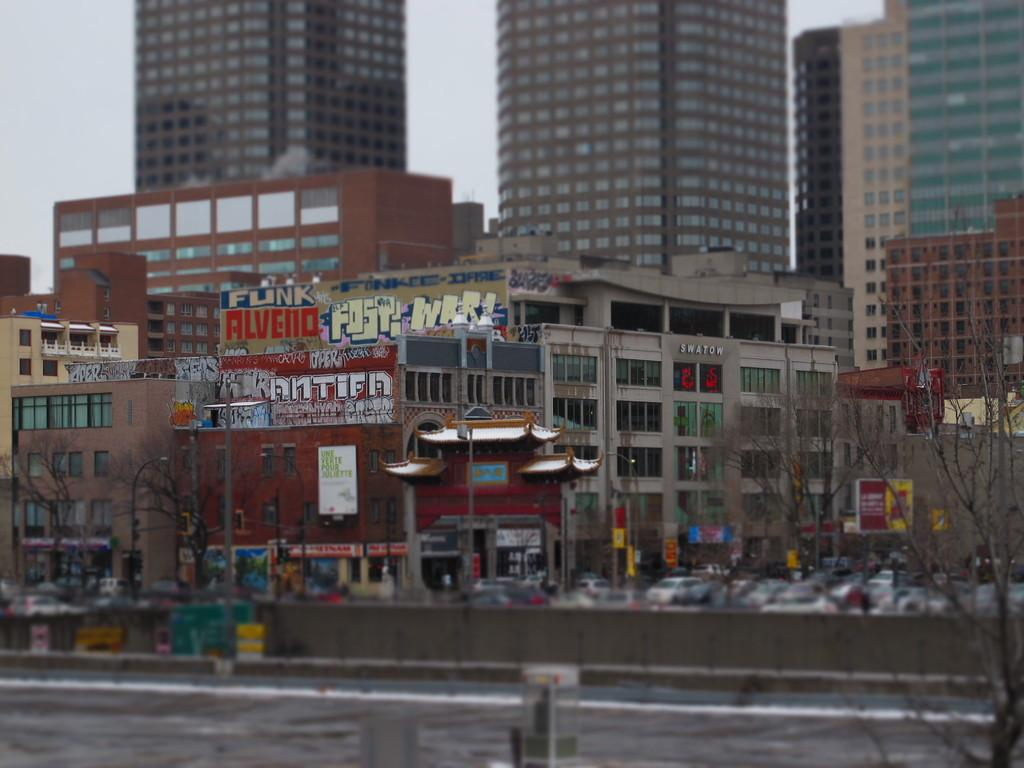What type of structures can be seen in the image? There are buildings in the image. What is located at the bottom of the image? There is a road at the bottom of the image. What is moving along the road in the image? Vehicles are visible on the road. What are the vertical structures in the image? There are poles in the image. What type of vegetation is present in the image? There are trees in the image. What is visible in the background of the image? The sky is visible in the background of the image. Where is the quince located in the image? There is no quince present in the image. What type of desk can be seen in the image? There is no desk present in the image. 